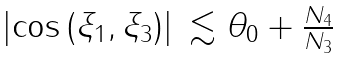<formula> <loc_0><loc_0><loc_500><loc_500>\begin{array} { l l } \left | \cos { ( \xi _ { 1 } , \xi _ { 3 } ) } \right | & \lesssim \theta _ { 0 } + \frac { N _ { 4 } } { N _ { 3 } } \\ \end{array}</formula> 